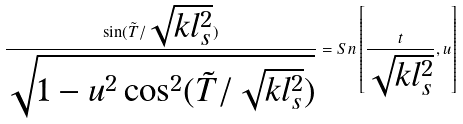Convert formula to latex. <formula><loc_0><loc_0><loc_500><loc_500>\frac { \sin ( \tilde { T } / \sqrt { k l _ { s } ^ { 2 } } ) } { \sqrt { 1 - u ^ { 2 } \cos ^ { 2 } ( \tilde { T } / \sqrt { k l _ { s } ^ { 2 } } ) } } = S n \left [ \frac { t } { \sqrt { k l _ { s } ^ { 2 } } } , u \right ]</formula> 